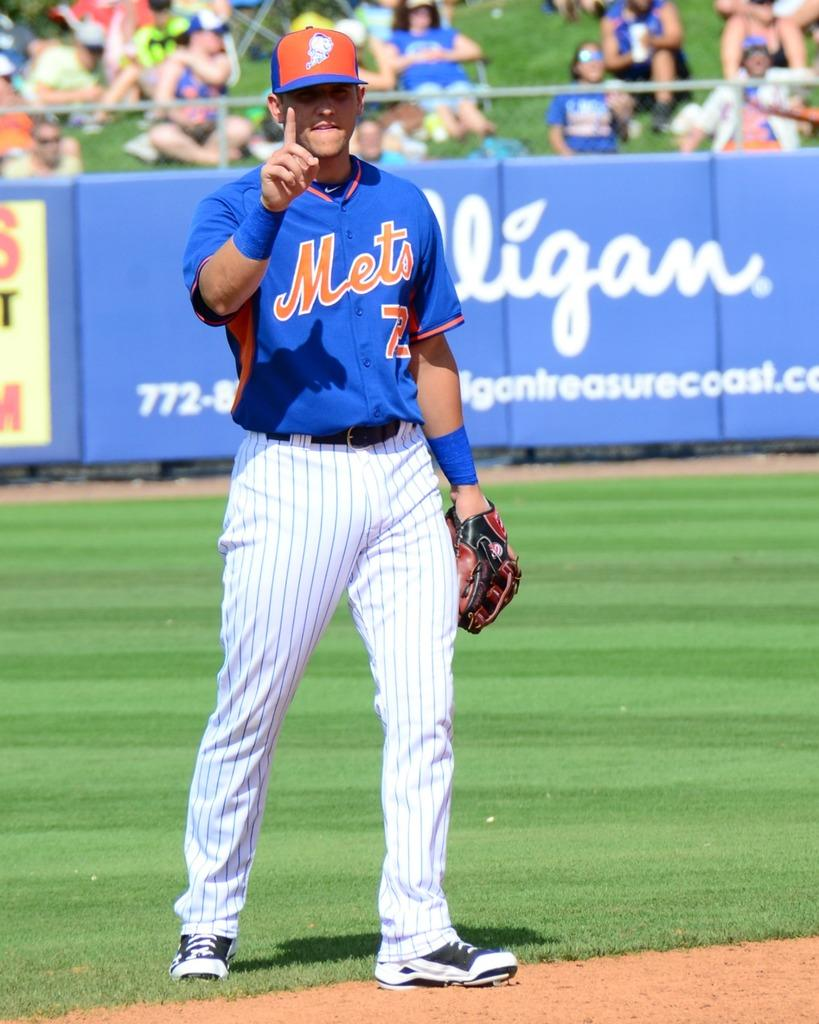<image>
Relay a brief, clear account of the picture shown. BASEBALL PLAYER IN BLUE METS SHIRT HOLDING UP ONE FINGER. 